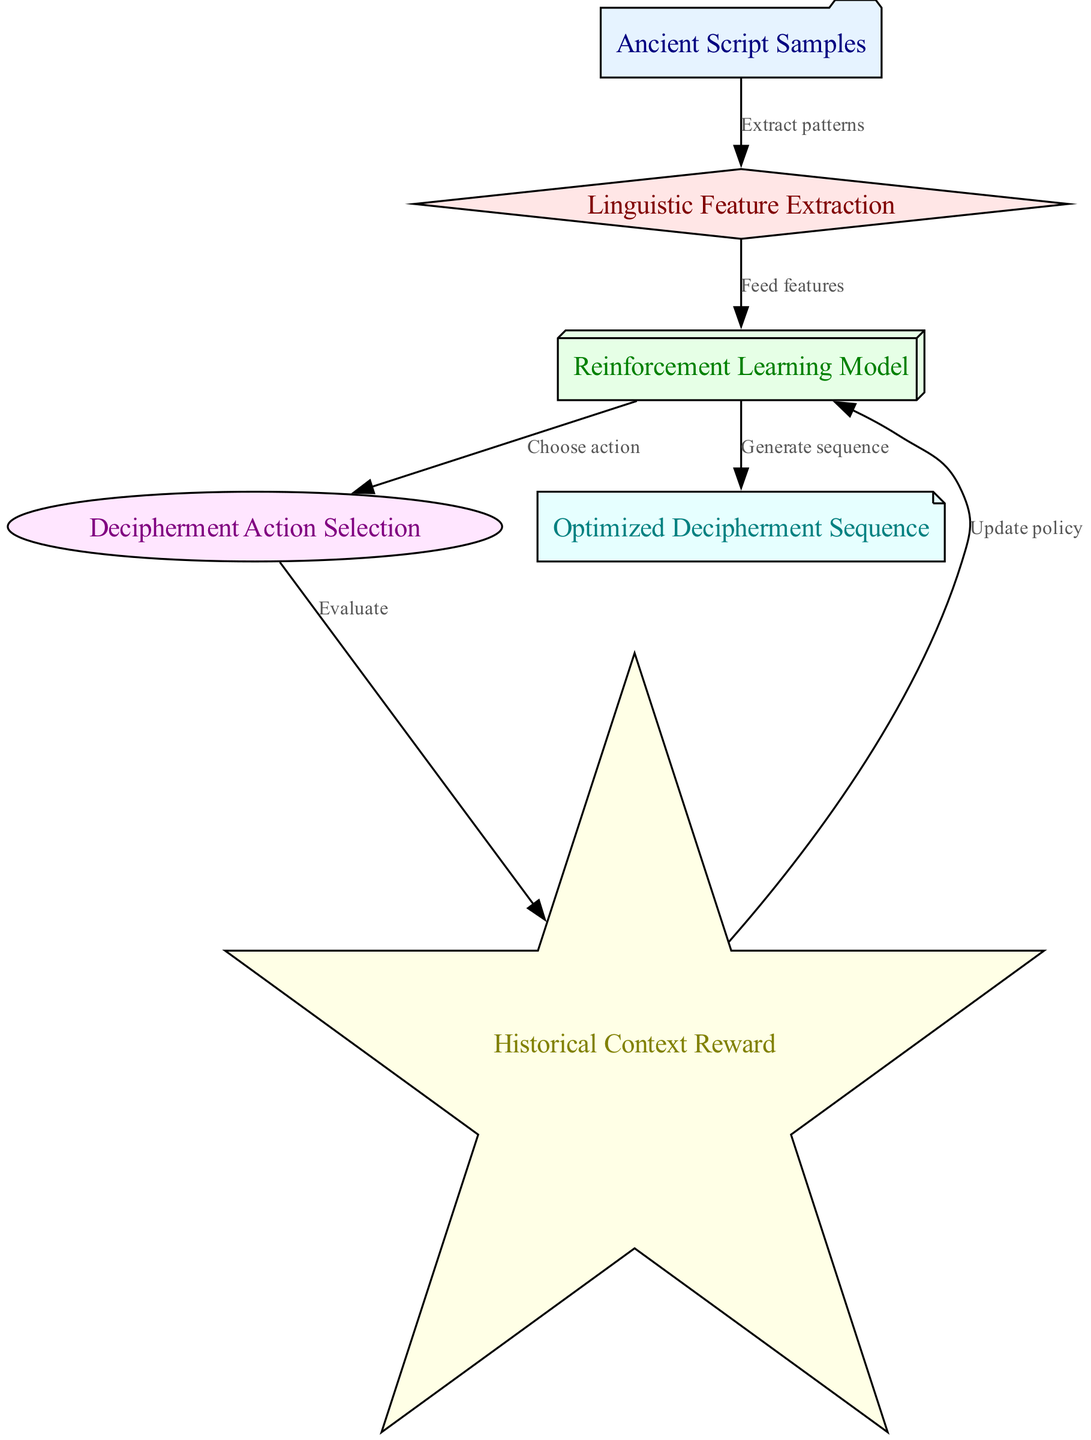What is the first node in the diagram? The first node in the diagram is labeled "Ancient Script Samples," which indicates the input for the model.
Answer: Ancient Script Samples How many nodes are present in the diagram? To determine the number of nodes, we can count each unique node listed: input, preprocess, model, action, reward, and output, which totals six nodes.
Answer: 6 What action does the model choose after processing the features? After processing the features, the model selects a "Decipherment Action," as indicated by the connection from the model node to the action node.
Answer: Decipherment Action What feedback does the model receive in the reward node? The model receives feedback related to "Historical Context Reward" from the reward node, which is evaluated based on the decipherment action.
Answer: Historical Context Reward What key process occurs between the action and reward nodes? The key process between the action and reward nodes is an "Evaluate" action, indicating that the model assesses the effectiveness of the chosen decipherment action.
Answer: Evaluate What is the purpose of the output node? The purpose of the output node is to represent the final result of the reinforcement learning model, which is the "Optimized Decipherment Sequence" generated after processing the input through the previous steps.
Answer: Optimized Decipherment Sequence How does the model update its strategy? The model updates its strategy through the process indicated by the edge labeled "Update policy," which shows that it incorporates the reward feedback to refine its action selections.
Answer: Update policy Which node feeds features to the reinforcement learning model? The node that feeds features to the reinforcement learning model is labeled "Linguistic Feature Extraction," showing it processes the input into a useful format for modeling.
Answer: Linguistic Feature Extraction How are the nodes related in sequence? The nodes are connected in a sequential flow from input to output, first extracting features, then processing through the model, selecting actions, evaluating results, updating strategy, and finally producing an optimized sequence.
Answer: Sequential flow from input to output 